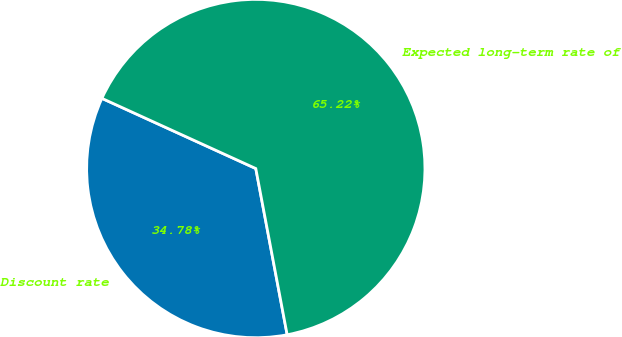Convert chart to OTSL. <chart><loc_0><loc_0><loc_500><loc_500><pie_chart><fcel>Discount rate<fcel>Expected long-term rate of<nl><fcel>34.78%<fcel>65.22%<nl></chart> 